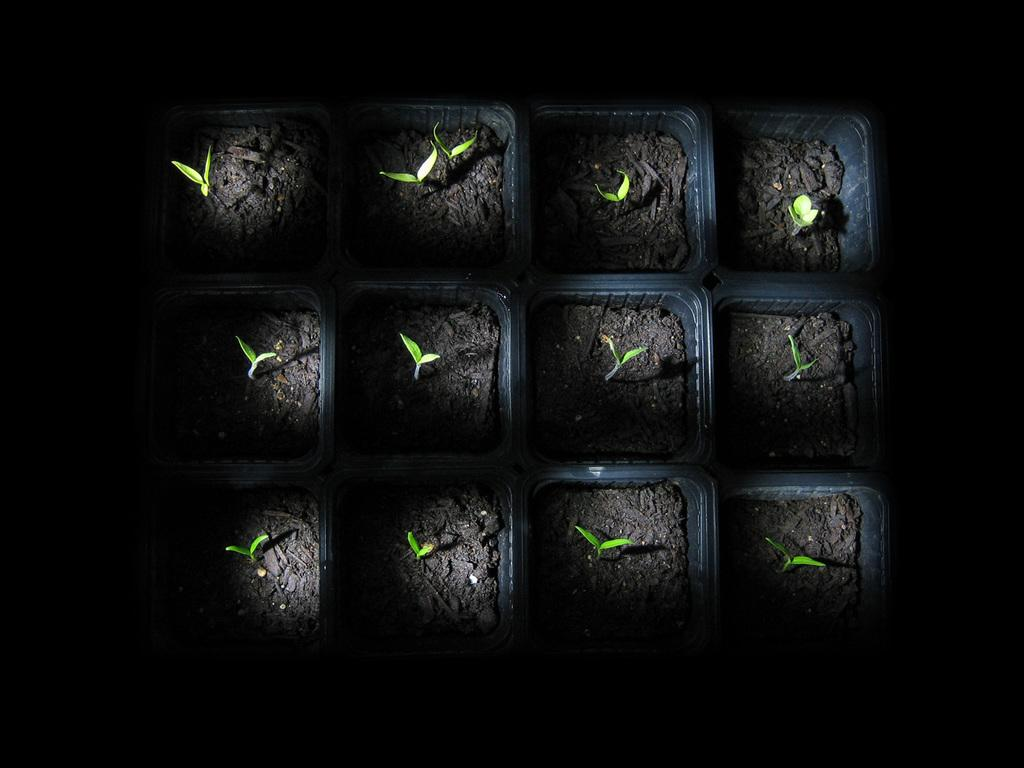What type of plants are in the image? There is a group of seedlings in the image. How are the seedlings arranged or organized in the image? The seedlings are in containers. What time of day is it in the image? The time of day cannot be determined from the image, as there are no indications of the time. How long does it take for the seedlings to grow in the image? The growth rate of the seedlings cannot be determined from the image, as there is no information about the time frame. 